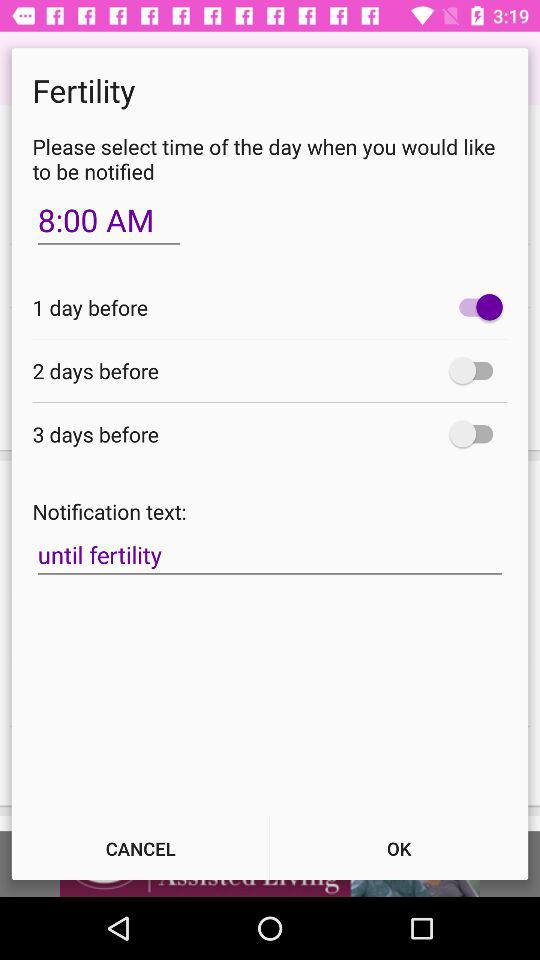What is the notification text? The notification text is "until fertility". 